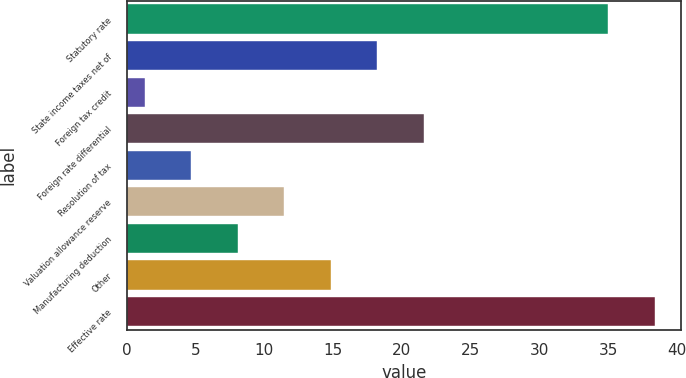<chart> <loc_0><loc_0><loc_500><loc_500><bar_chart><fcel>Statutory rate<fcel>State income taxes net of<fcel>Foreign tax credit<fcel>Foreign rate differential<fcel>Resolution of tax<fcel>Valuation allowance reserve<fcel>Manufacturing deduction<fcel>Other<fcel>Effective rate<nl><fcel>35<fcel>18.2<fcel>1.3<fcel>21.58<fcel>4.68<fcel>11.44<fcel>8.06<fcel>14.82<fcel>38.38<nl></chart> 